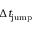Convert formula to latex. <formula><loc_0><loc_0><loc_500><loc_500>\Delta t _ { j u m p }</formula> 